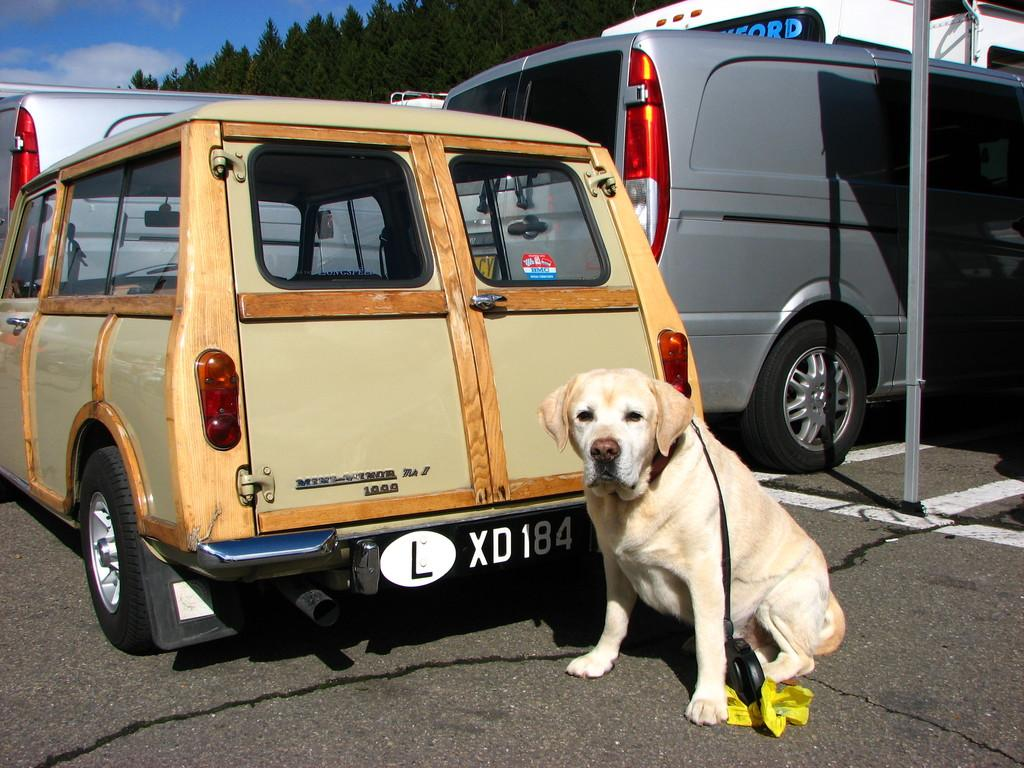What type of animal can be seen in the image? There is a dog in the image. Where is the dog located in the image? The dog is sitting on the road. What is behind the dog in the image? There are vehicles behind the dog. What can be seen in the background of the image? There are trees in the background of the image. What type of argument is the dog having with the trees in the background? There is no argument present in the image; the dog is sitting on the road, and there are trees in the background. Can you see the dog's heart beating in the image? The image does not show the dog's internal organs, so it is not possible to see the dog's heart beating. 